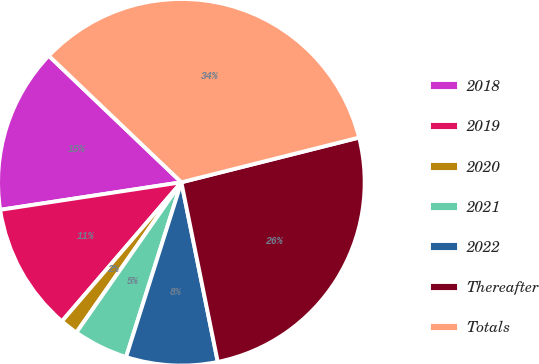<chart> <loc_0><loc_0><loc_500><loc_500><pie_chart><fcel>2018<fcel>2019<fcel>2020<fcel>2021<fcel>2022<fcel>Thereafter<fcel>Totals<nl><fcel>14.53%<fcel>11.3%<fcel>1.59%<fcel>4.83%<fcel>8.06%<fcel>25.74%<fcel>33.95%<nl></chart> 